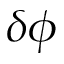<formula> <loc_0><loc_0><loc_500><loc_500>\delta \phi</formula> 